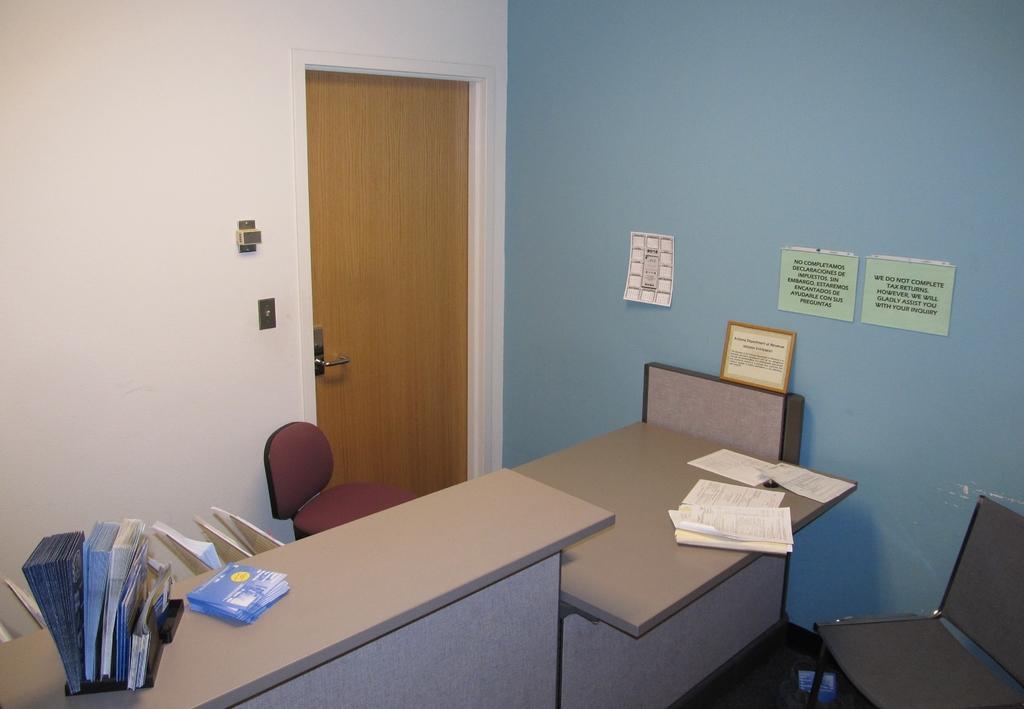Please provide a concise description of this image. In this image there are papers and pamphlets in a stand on the tables, there are chairs, papers stick to the wall, frame , door with a door handle, wall. 